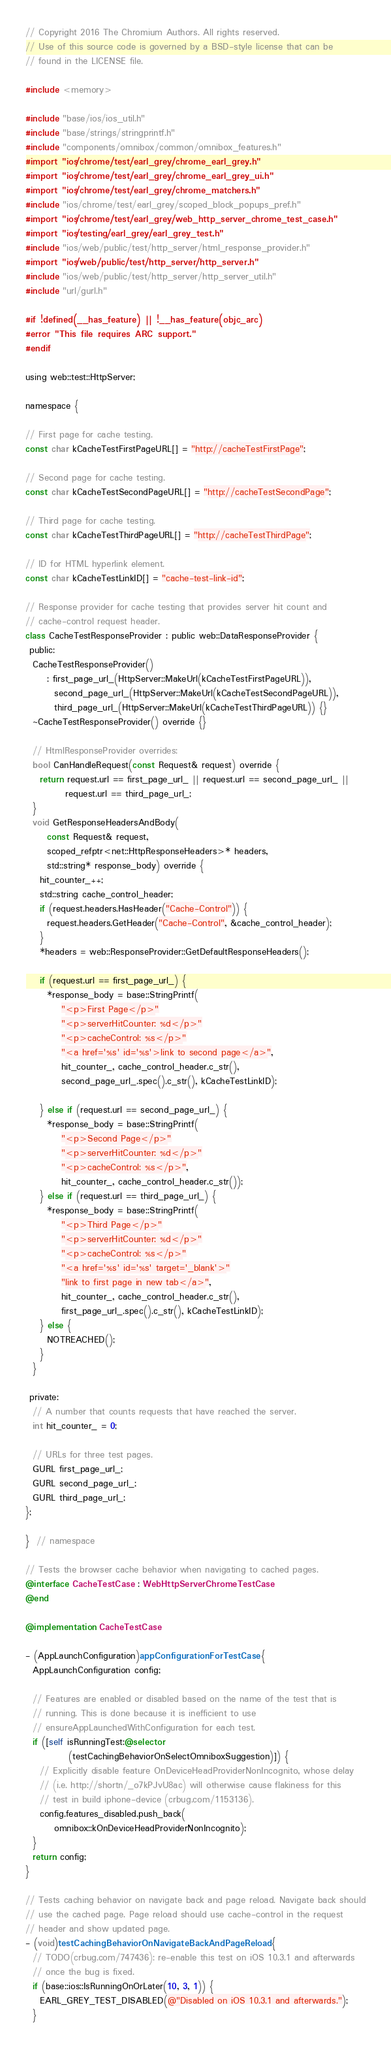Convert code to text. <code><loc_0><loc_0><loc_500><loc_500><_ObjectiveC_>// Copyright 2016 The Chromium Authors. All rights reserved.
// Use of this source code is governed by a BSD-style license that can be
// found in the LICENSE file.

#include <memory>

#include "base/ios/ios_util.h"
#include "base/strings/stringprintf.h"
#include "components/omnibox/common/omnibox_features.h"
#import "ios/chrome/test/earl_grey/chrome_earl_grey.h"
#import "ios/chrome/test/earl_grey/chrome_earl_grey_ui.h"
#import "ios/chrome/test/earl_grey/chrome_matchers.h"
#include "ios/chrome/test/earl_grey/scoped_block_popups_pref.h"
#import "ios/chrome/test/earl_grey/web_http_server_chrome_test_case.h"
#import "ios/testing/earl_grey/earl_grey_test.h"
#include "ios/web/public/test/http_server/html_response_provider.h"
#import "ios/web/public/test/http_server/http_server.h"
#include "ios/web/public/test/http_server/http_server_util.h"
#include "url/gurl.h"

#if !defined(__has_feature) || !__has_feature(objc_arc)
#error "This file requires ARC support."
#endif

using web::test::HttpServer;

namespace {

// First page for cache testing.
const char kCacheTestFirstPageURL[] = "http://cacheTestFirstPage";

// Second page for cache testing.
const char kCacheTestSecondPageURL[] = "http://cacheTestSecondPage";

// Third page for cache testing.
const char kCacheTestThirdPageURL[] = "http://cacheTestThirdPage";

// ID for HTML hyperlink element.
const char kCacheTestLinkID[] = "cache-test-link-id";

// Response provider for cache testing that provides server hit count and
// cache-control request header.
class CacheTestResponseProvider : public web::DataResponseProvider {
 public:
  CacheTestResponseProvider()
      : first_page_url_(HttpServer::MakeUrl(kCacheTestFirstPageURL)),
        second_page_url_(HttpServer::MakeUrl(kCacheTestSecondPageURL)),
        third_page_url_(HttpServer::MakeUrl(kCacheTestThirdPageURL)) {}
  ~CacheTestResponseProvider() override {}

  // HtmlResponseProvider overrides:
  bool CanHandleRequest(const Request& request) override {
    return request.url == first_page_url_ || request.url == second_page_url_ ||
           request.url == third_page_url_;
  }
  void GetResponseHeadersAndBody(
      const Request& request,
      scoped_refptr<net::HttpResponseHeaders>* headers,
      std::string* response_body) override {
    hit_counter_++;
    std::string cache_control_header;
    if (request.headers.HasHeader("Cache-Control")) {
      request.headers.GetHeader("Cache-Control", &cache_control_header);
    }
    *headers = web::ResponseProvider::GetDefaultResponseHeaders();

    if (request.url == first_page_url_) {
      *response_body = base::StringPrintf(
          "<p>First Page</p>"
          "<p>serverHitCounter: %d</p>"
          "<p>cacheControl: %s</p>"
          "<a href='%s' id='%s'>link to second page</a>",
          hit_counter_, cache_control_header.c_str(),
          second_page_url_.spec().c_str(), kCacheTestLinkID);

    } else if (request.url == second_page_url_) {
      *response_body = base::StringPrintf(
          "<p>Second Page</p>"
          "<p>serverHitCounter: %d</p>"
          "<p>cacheControl: %s</p>",
          hit_counter_, cache_control_header.c_str());
    } else if (request.url == third_page_url_) {
      *response_body = base::StringPrintf(
          "<p>Third Page</p>"
          "<p>serverHitCounter: %d</p>"
          "<p>cacheControl: %s</p>"
          "<a href='%s' id='%s' target='_blank'>"
          "link to first page in new tab</a>",
          hit_counter_, cache_control_header.c_str(),
          first_page_url_.spec().c_str(), kCacheTestLinkID);
    } else {
      NOTREACHED();
    }
  }

 private:
  // A number that counts requests that have reached the server.
  int hit_counter_ = 0;

  // URLs for three test pages.
  GURL first_page_url_;
  GURL second_page_url_;
  GURL third_page_url_;
};

}  // namespace

// Tests the browser cache behavior when navigating to cached pages.
@interface CacheTestCase : WebHttpServerChromeTestCase
@end

@implementation CacheTestCase

- (AppLaunchConfiguration)appConfigurationForTestCase {
  AppLaunchConfiguration config;

  // Features are enabled or disabled based on the name of the test that is
  // running. This is done because it is inefficient to use
  // ensureAppLaunchedWithConfiguration for each test.
  if ([self isRunningTest:@selector
            (testCachingBehaviorOnSelectOmniboxSuggestion)]) {
    // Explicitly disable feature OnDeviceHeadProviderNonIncognito, whose delay
    // (i.e. http://shortn/_o7kPJvU8ac) will otherwise cause flakiness for this
    // test in build iphone-device (crbug.com/1153136).
    config.features_disabled.push_back(
        omnibox::kOnDeviceHeadProviderNonIncognito);
  }
  return config;
}

// Tests caching behavior on navigate back and page reload. Navigate back should
// use the cached page. Page reload should use cache-control in the request
// header and show updated page.
- (void)testCachingBehaviorOnNavigateBackAndPageReload {
  // TODO(crbug.com/747436): re-enable this test on iOS 10.3.1 and afterwards
  // once the bug is fixed.
  if (base::ios::IsRunningOnOrLater(10, 3, 1)) {
    EARL_GREY_TEST_DISABLED(@"Disabled on iOS 10.3.1 and afterwards.");
  }
</code> 